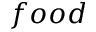Convert formula to latex. <formula><loc_0><loc_0><loc_500><loc_500>f o o d</formula> 